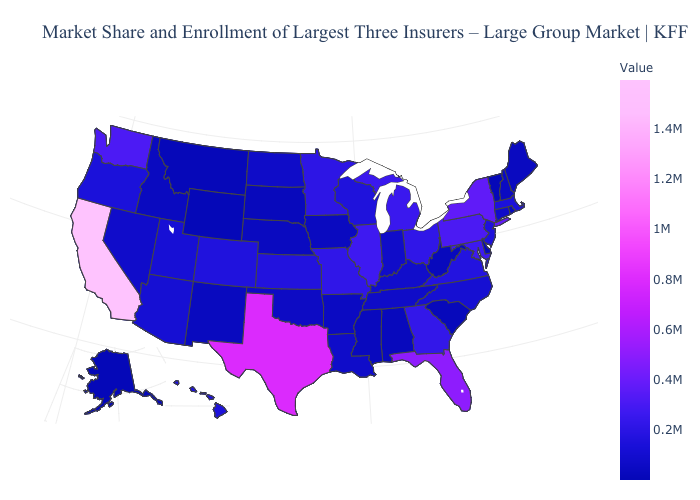Does Georgia have a higher value than Florida?
Write a very short answer. No. Among the states that border Wisconsin , does Michigan have the lowest value?
Give a very brief answer. No. Among the states that border Idaho , which have the highest value?
Quick response, please. Washington. Which states have the highest value in the USA?
Answer briefly. California. Which states have the lowest value in the USA?
Be succinct. Wyoming. Does New Hampshire have a lower value than Georgia?
Answer briefly. Yes. 